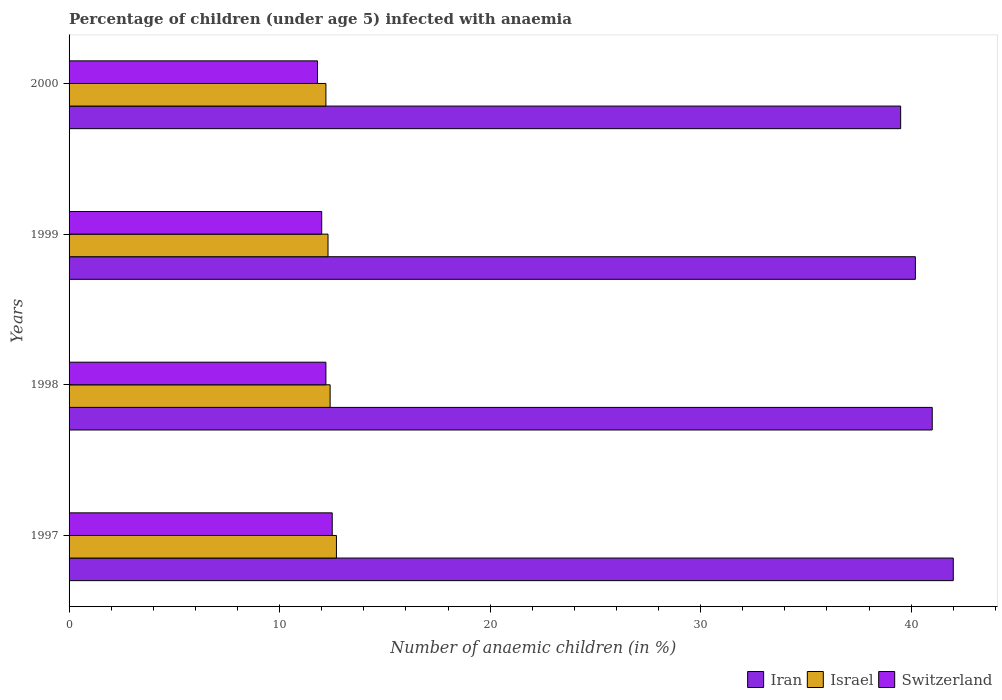How many different coloured bars are there?
Offer a terse response. 3. How many bars are there on the 2nd tick from the top?
Give a very brief answer. 3. What is the label of the 1st group of bars from the top?
Provide a succinct answer. 2000. In how many cases, is the number of bars for a given year not equal to the number of legend labels?
Provide a short and direct response. 0. In which year was the percentage of children infected with anaemia in in Iran minimum?
Make the answer very short. 2000. What is the total percentage of children infected with anaemia in in Switzerland in the graph?
Your response must be concise. 48.5. What is the difference between the percentage of children infected with anaemia in in Iran in 2000 and the percentage of children infected with anaemia in in Israel in 1997?
Offer a very short reply. 26.8. What is the average percentage of children infected with anaemia in in Israel per year?
Offer a terse response. 12.4. In the year 1999, what is the difference between the percentage of children infected with anaemia in in Switzerland and percentage of children infected with anaemia in in Israel?
Make the answer very short. -0.3. In how many years, is the percentage of children infected with anaemia in in Israel greater than 4 %?
Offer a very short reply. 4. What is the ratio of the percentage of children infected with anaemia in in Switzerland in 1997 to that in 1999?
Provide a succinct answer. 1.04. Is the percentage of children infected with anaemia in in Switzerland in 1997 less than that in 2000?
Your answer should be very brief. No. Is the difference between the percentage of children infected with anaemia in in Switzerland in 1997 and 2000 greater than the difference between the percentage of children infected with anaemia in in Israel in 1997 and 2000?
Keep it short and to the point. Yes. In how many years, is the percentage of children infected with anaemia in in Israel greater than the average percentage of children infected with anaemia in in Israel taken over all years?
Make the answer very short. 1. What does the 1st bar from the top in 1998 represents?
Your answer should be very brief. Switzerland. What does the 1st bar from the bottom in 2000 represents?
Make the answer very short. Iran. Is it the case that in every year, the sum of the percentage of children infected with anaemia in in Israel and percentage of children infected with anaemia in in Iran is greater than the percentage of children infected with anaemia in in Switzerland?
Your response must be concise. Yes. How many years are there in the graph?
Your answer should be very brief. 4. Does the graph contain any zero values?
Make the answer very short. No. How many legend labels are there?
Give a very brief answer. 3. What is the title of the graph?
Your answer should be very brief. Percentage of children (under age 5) infected with anaemia. What is the label or title of the X-axis?
Keep it short and to the point. Number of anaemic children (in %). What is the label or title of the Y-axis?
Provide a short and direct response. Years. What is the Number of anaemic children (in %) in Israel in 1997?
Ensure brevity in your answer.  12.7. What is the Number of anaemic children (in %) in Iran in 1998?
Provide a short and direct response. 41. What is the Number of anaemic children (in %) in Israel in 1998?
Keep it short and to the point. 12.4. What is the Number of anaemic children (in %) of Iran in 1999?
Your answer should be very brief. 40.2. What is the Number of anaemic children (in %) of Israel in 1999?
Provide a short and direct response. 12.3. What is the Number of anaemic children (in %) in Switzerland in 1999?
Your answer should be very brief. 12. What is the Number of anaemic children (in %) of Iran in 2000?
Your answer should be very brief. 39.5. What is the Number of anaemic children (in %) of Switzerland in 2000?
Your response must be concise. 11.8. Across all years, what is the maximum Number of anaemic children (in %) in Iran?
Keep it short and to the point. 42. Across all years, what is the maximum Number of anaemic children (in %) of Israel?
Give a very brief answer. 12.7. Across all years, what is the maximum Number of anaemic children (in %) of Switzerland?
Your answer should be compact. 12.5. Across all years, what is the minimum Number of anaemic children (in %) in Iran?
Your response must be concise. 39.5. Across all years, what is the minimum Number of anaemic children (in %) of Israel?
Make the answer very short. 12.2. Across all years, what is the minimum Number of anaemic children (in %) of Switzerland?
Offer a terse response. 11.8. What is the total Number of anaemic children (in %) in Iran in the graph?
Make the answer very short. 162.7. What is the total Number of anaemic children (in %) in Israel in the graph?
Your answer should be very brief. 49.6. What is the total Number of anaemic children (in %) in Switzerland in the graph?
Offer a terse response. 48.5. What is the difference between the Number of anaemic children (in %) in Iran in 1997 and that in 1998?
Provide a succinct answer. 1. What is the difference between the Number of anaemic children (in %) of Israel in 1997 and that in 1998?
Ensure brevity in your answer.  0.3. What is the difference between the Number of anaemic children (in %) of Switzerland in 1997 and that in 1998?
Provide a short and direct response. 0.3. What is the difference between the Number of anaemic children (in %) in Israel in 1997 and that in 1999?
Ensure brevity in your answer.  0.4. What is the difference between the Number of anaemic children (in %) of Switzerland in 1997 and that in 1999?
Offer a terse response. 0.5. What is the difference between the Number of anaemic children (in %) of Iran in 1997 and that in 2000?
Offer a very short reply. 2.5. What is the difference between the Number of anaemic children (in %) of Israel in 1997 and that in 2000?
Ensure brevity in your answer.  0.5. What is the difference between the Number of anaemic children (in %) in Switzerland in 1998 and that in 1999?
Ensure brevity in your answer.  0.2. What is the difference between the Number of anaemic children (in %) in Iran in 1998 and that in 2000?
Keep it short and to the point. 1.5. What is the difference between the Number of anaemic children (in %) in Iran in 1999 and that in 2000?
Give a very brief answer. 0.7. What is the difference between the Number of anaemic children (in %) in Iran in 1997 and the Number of anaemic children (in %) in Israel in 1998?
Your answer should be very brief. 29.6. What is the difference between the Number of anaemic children (in %) in Iran in 1997 and the Number of anaemic children (in %) in Switzerland in 1998?
Provide a short and direct response. 29.8. What is the difference between the Number of anaemic children (in %) of Israel in 1997 and the Number of anaemic children (in %) of Switzerland in 1998?
Your response must be concise. 0.5. What is the difference between the Number of anaemic children (in %) of Iran in 1997 and the Number of anaemic children (in %) of Israel in 1999?
Offer a terse response. 29.7. What is the difference between the Number of anaemic children (in %) in Israel in 1997 and the Number of anaemic children (in %) in Switzerland in 1999?
Ensure brevity in your answer.  0.7. What is the difference between the Number of anaemic children (in %) in Iran in 1997 and the Number of anaemic children (in %) in Israel in 2000?
Your answer should be compact. 29.8. What is the difference between the Number of anaemic children (in %) in Iran in 1997 and the Number of anaemic children (in %) in Switzerland in 2000?
Ensure brevity in your answer.  30.2. What is the difference between the Number of anaemic children (in %) of Israel in 1997 and the Number of anaemic children (in %) of Switzerland in 2000?
Your answer should be compact. 0.9. What is the difference between the Number of anaemic children (in %) in Iran in 1998 and the Number of anaemic children (in %) in Israel in 1999?
Keep it short and to the point. 28.7. What is the difference between the Number of anaemic children (in %) of Iran in 1998 and the Number of anaemic children (in %) of Switzerland in 1999?
Your answer should be compact. 29. What is the difference between the Number of anaemic children (in %) in Israel in 1998 and the Number of anaemic children (in %) in Switzerland in 1999?
Provide a short and direct response. 0.4. What is the difference between the Number of anaemic children (in %) of Iran in 1998 and the Number of anaemic children (in %) of Israel in 2000?
Offer a terse response. 28.8. What is the difference between the Number of anaemic children (in %) of Iran in 1998 and the Number of anaemic children (in %) of Switzerland in 2000?
Your answer should be very brief. 29.2. What is the difference between the Number of anaemic children (in %) in Iran in 1999 and the Number of anaemic children (in %) in Israel in 2000?
Provide a succinct answer. 28. What is the difference between the Number of anaemic children (in %) in Iran in 1999 and the Number of anaemic children (in %) in Switzerland in 2000?
Your answer should be compact. 28.4. What is the difference between the Number of anaemic children (in %) of Israel in 1999 and the Number of anaemic children (in %) of Switzerland in 2000?
Your answer should be compact. 0.5. What is the average Number of anaemic children (in %) in Iran per year?
Your response must be concise. 40.67. What is the average Number of anaemic children (in %) in Switzerland per year?
Provide a succinct answer. 12.12. In the year 1997, what is the difference between the Number of anaemic children (in %) of Iran and Number of anaemic children (in %) of Israel?
Your response must be concise. 29.3. In the year 1997, what is the difference between the Number of anaemic children (in %) of Iran and Number of anaemic children (in %) of Switzerland?
Offer a terse response. 29.5. In the year 1998, what is the difference between the Number of anaemic children (in %) of Iran and Number of anaemic children (in %) of Israel?
Provide a short and direct response. 28.6. In the year 1998, what is the difference between the Number of anaemic children (in %) of Iran and Number of anaemic children (in %) of Switzerland?
Give a very brief answer. 28.8. In the year 1998, what is the difference between the Number of anaemic children (in %) of Israel and Number of anaemic children (in %) of Switzerland?
Provide a short and direct response. 0.2. In the year 1999, what is the difference between the Number of anaemic children (in %) in Iran and Number of anaemic children (in %) in Israel?
Your answer should be compact. 27.9. In the year 1999, what is the difference between the Number of anaemic children (in %) of Iran and Number of anaemic children (in %) of Switzerland?
Offer a very short reply. 28.2. In the year 2000, what is the difference between the Number of anaemic children (in %) in Iran and Number of anaemic children (in %) in Israel?
Provide a short and direct response. 27.3. In the year 2000, what is the difference between the Number of anaemic children (in %) in Iran and Number of anaemic children (in %) in Switzerland?
Provide a succinct answer. 27.7. What is the ratio of the Number of anaemic children (in %) in Iran in 1997 to that in 1998?
Make the answer very short. 1.02. What is the ratio of the Number of anaemic children (in %) of Israel in 1997 to that in 1998?
Make the answer very short. 1.02. What is the ratio of the Number of anaemic children (in %) in Switzerland in 1997 to that in 1998?
Offer a terse response. 1.02. What is the ratio of the Number of anaemic children (in %) in Iran in 1997 to that in 1999?
Give a very brief answer. 1.04. What is the ratio of the Number of anaemic children (in %) in Israel in 1997 to that in 1999?
Make the answer very short. 1.03. What is the ratio of the Number of anaemic children (in %) in Switzerland in 1997 to that in 1999?
Offer a very short reply. 1.04. What is the ratio of the Number of anaemic children (in %) in Iran in 1997 to that in 2000?
Ensure brevity in your answer.  1.06. What is the ratio of the Number of anaemic children (in %) of Israel in 1997 to that in 2000?
Ensure brevity in your answer.  1.04. What is the ratio of the Number of anaemic children (in %) in Switzerland in 1997 to that in 2000?
Your answer should be very brief. 1.06. What is the ratio of the Number of anaemic children (in %) in Iran in 1998 to that in 1999?
Provide a short and direct response. 1.02. What is the ratio of the Number of anaemic children (in %) of Israel in 1998 to that in 1999?
Offer a very short reply. 1.01. What is the ratio of the Number of anaemic children (in %) of Switzerland in 1998 to that in 1999?
Offer a very short reply. 1.02. What is the ratio of the Number of anaemic children (in %) in Iran in 1998 to that in 2000?
Give a very brief answer. 1.04. What is the ratio of the Number of anaemic children (in %) of Israel in 1998 to that in 2000?
Give a very brief answer. 1.02. What is the ratio of the Number of anaemic children (in %) of Switzerland in 1998 to that in 2000?
Give a very brief answer. 1.03. What is the ratio of the Number of anaemic children (in %) in Iran in 1999 to that in 2000?
Keep it short and to the point. 1.02. What is the ratio of the Number of anaemic children (in %) in Israel in 1999 to that in 2000?
Give a very brief answer. 1.01. What is the ratio of the Number of anaemic children (in %) in Switzerland in 1999 to that in 2000?
Offer a terse response. 1.02. What is the difference between the highest and the second highest Number of anaemic children (in %) in Iran?
Offer a terse response. 1. What is the difference between the highest and the second highest Number of anaemic children (in %) in Israel?
Keep it short and to the point. 0.3. What is the difference between the highest and the second highest Number of anaemic children (in %) in Switzerland?
Provide a short and direct response. 0.3. What is the difference between the highest and the lowest Number of anaemic children (in %) in Iran?
Give a very brief answer. 2.5. What is the difference between the highest and the lowest Number of anaemic children (in %) of Israel?
Keep it short and to the point. 0.5. 